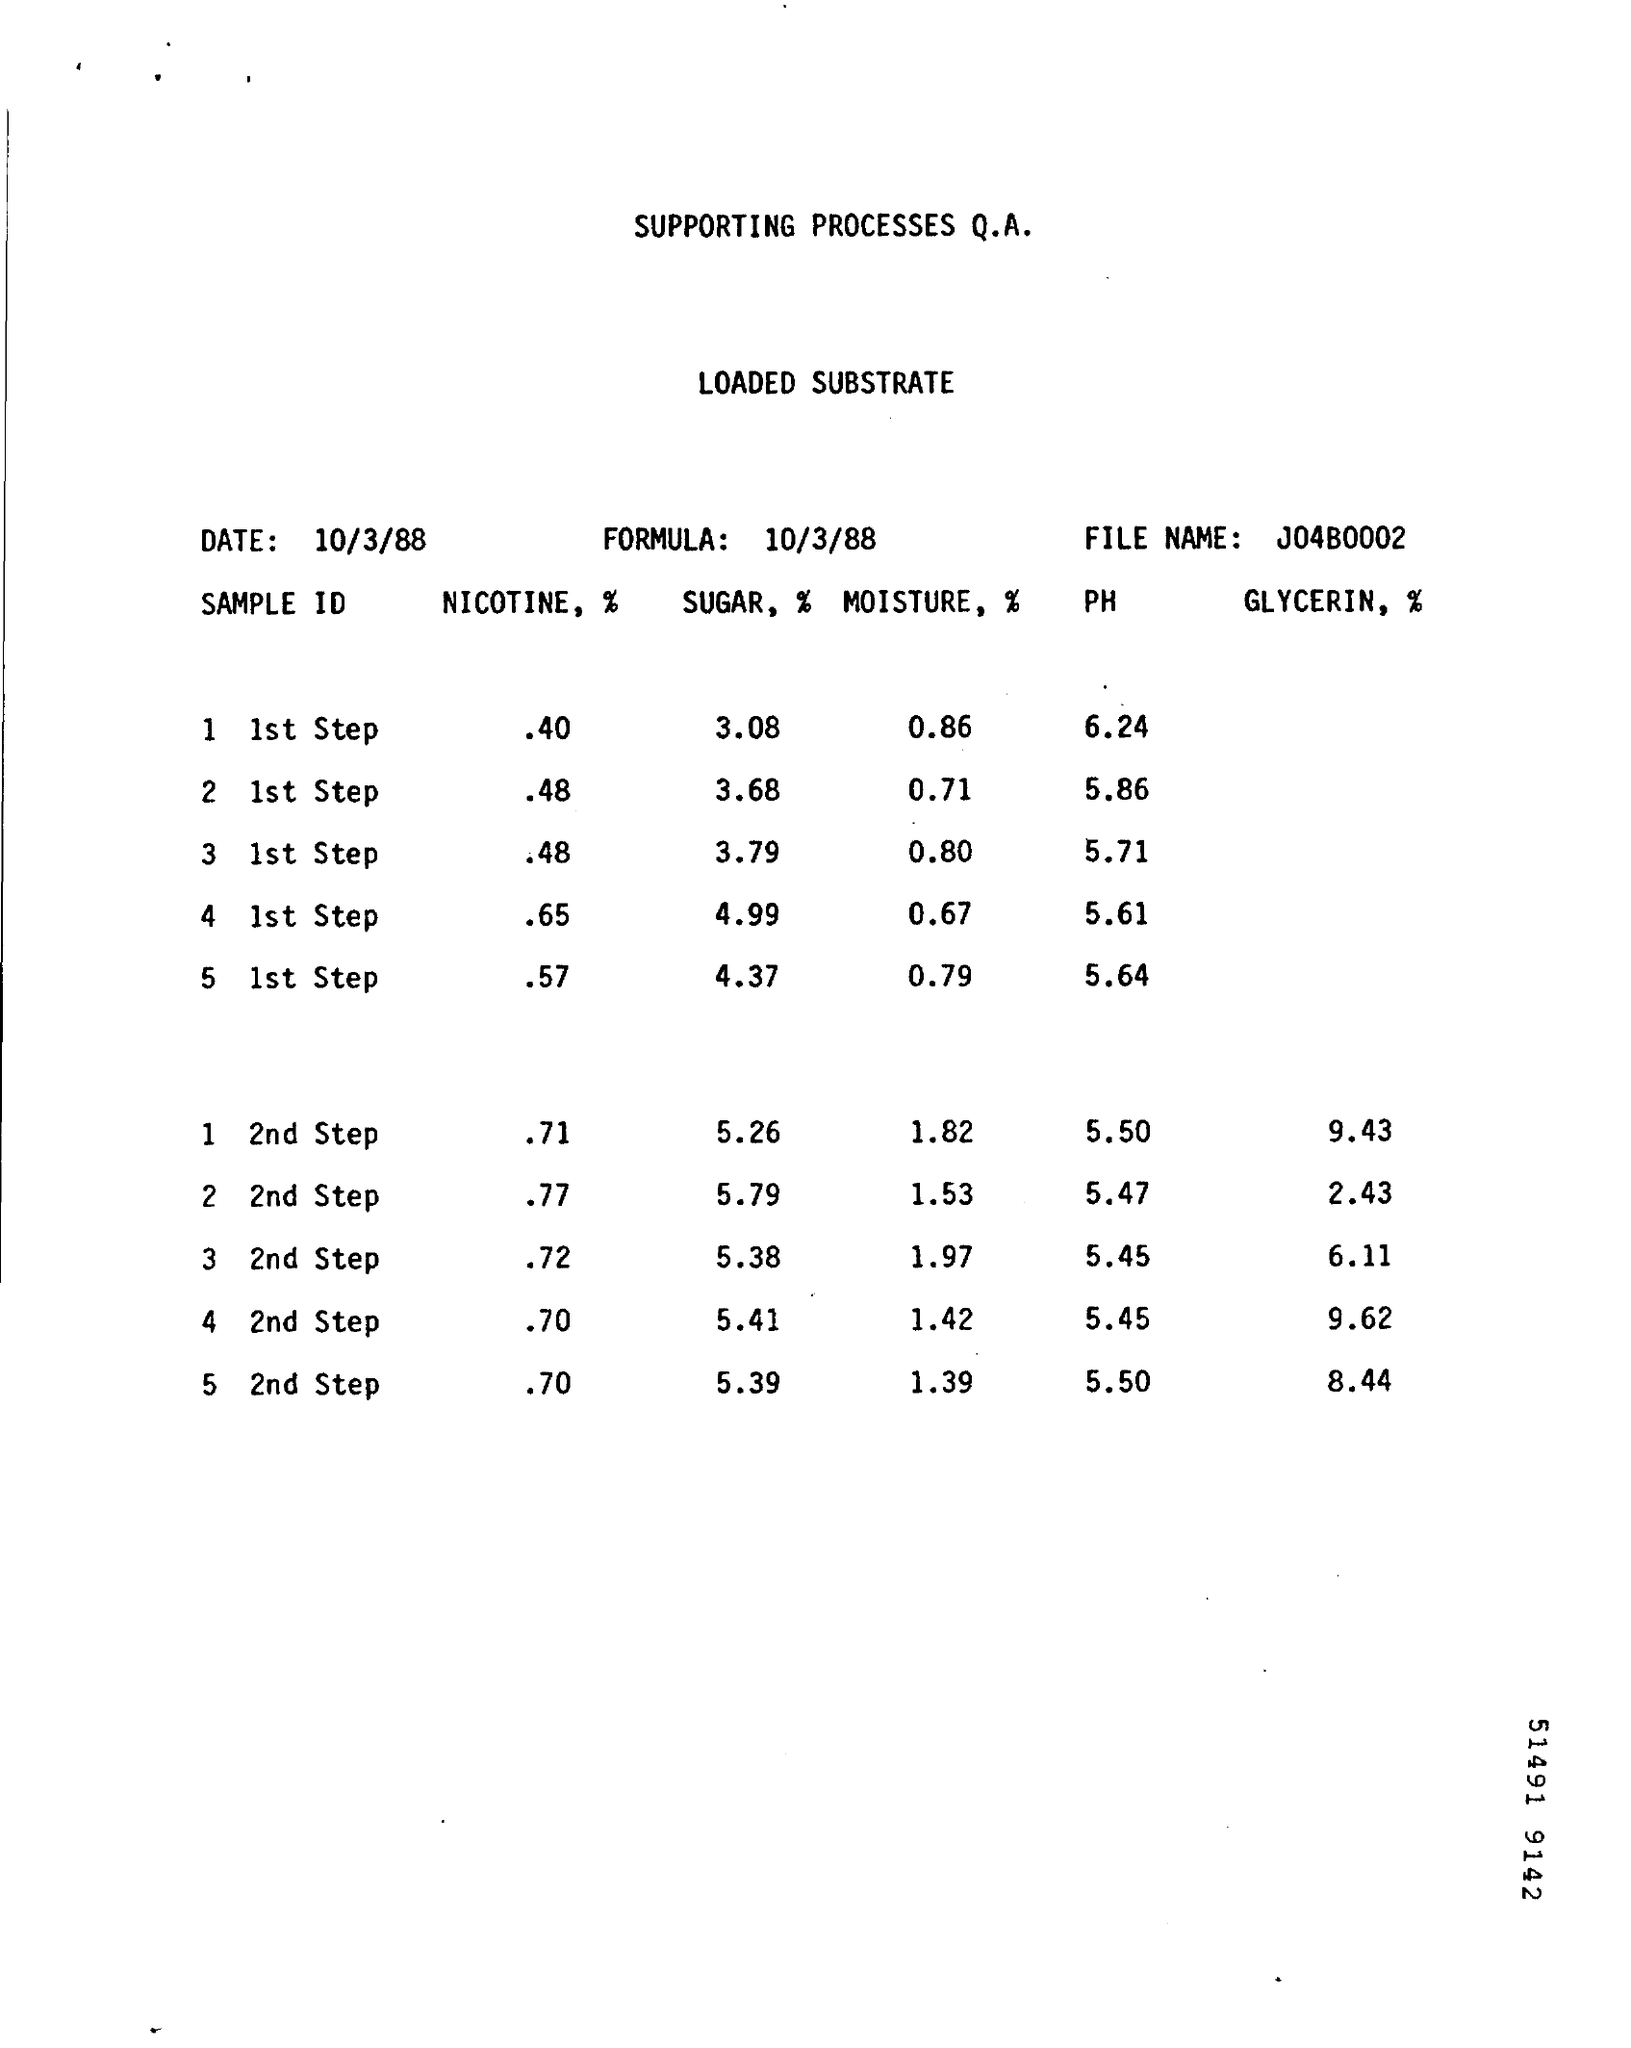Specify some key components in this picture. The date mentioned in the top left is October 3, 1988. The file name is "J04B0002." It is a declaration of the file name and its contents. The formula for the date is October 3, 1988. 